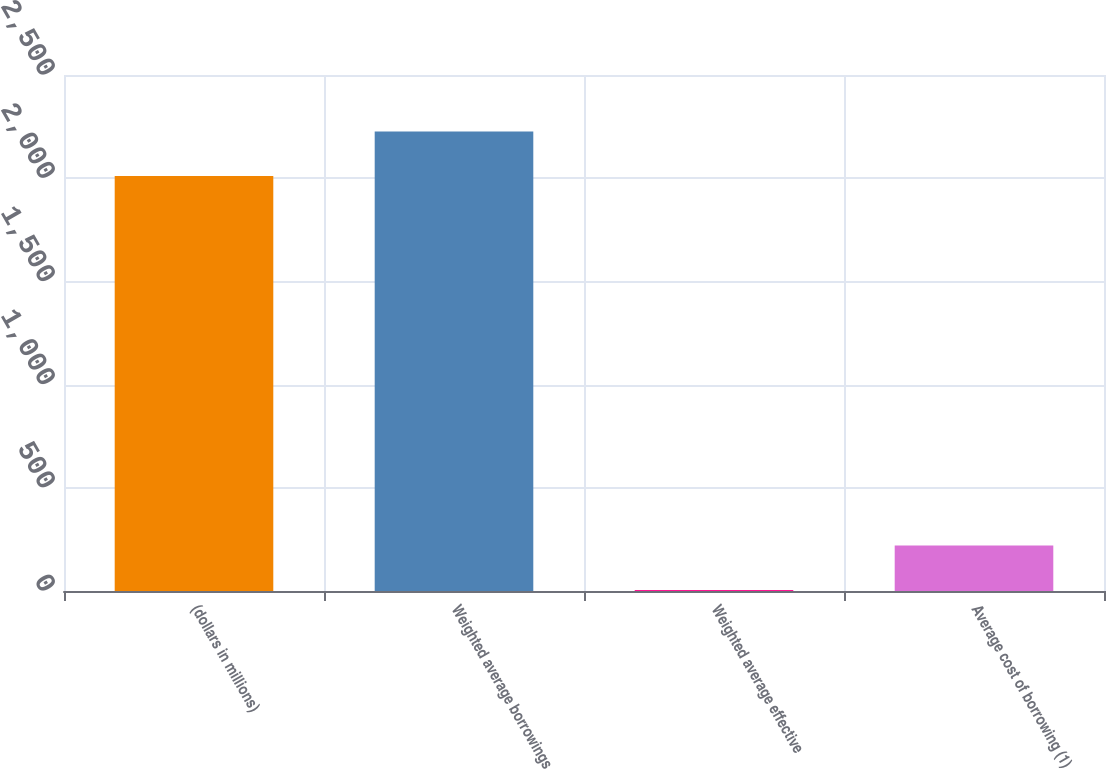Convert chart to OTSL. <chart><loc_0><loc_0><loc_500><loc_500><bar_chart><fcel>(dollars in millions)<fcel>Weighted average borrowings<fcel>Weighted average effective<fcel>Average cost of borrowing (1)<nl><fcel>2011<fcel>2226.06<fcel>5.18<fcel>220.24<nl></chart> 